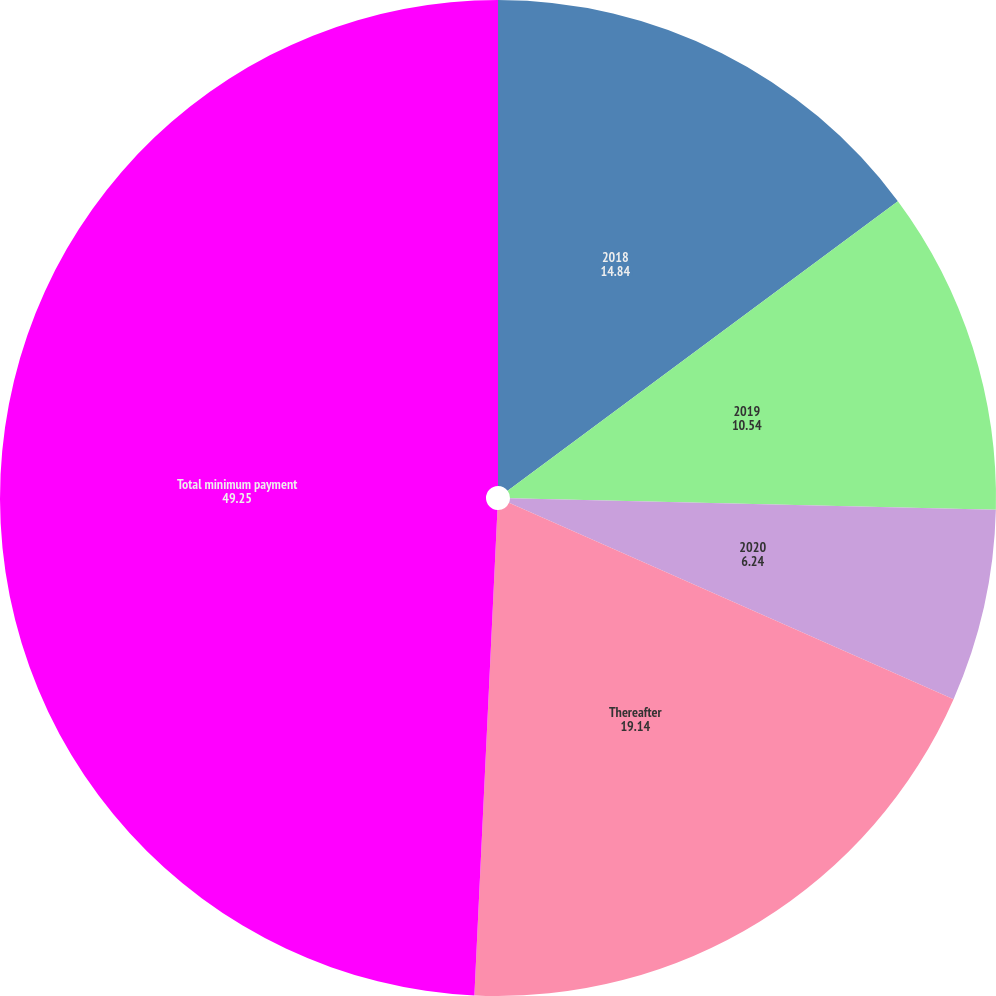<chart> <loc_0><loc_0><loc_500><loc_500><pie_chart><fcel>2018<fcel>2019<fcel>2020<fcel>Thereafter<fcel>Total minimum payment<nl><fcel>14.84%<fcel>10.54%<fcel>6.24%<fcel>19.14%<fcel>49.25%<nl></chart> 